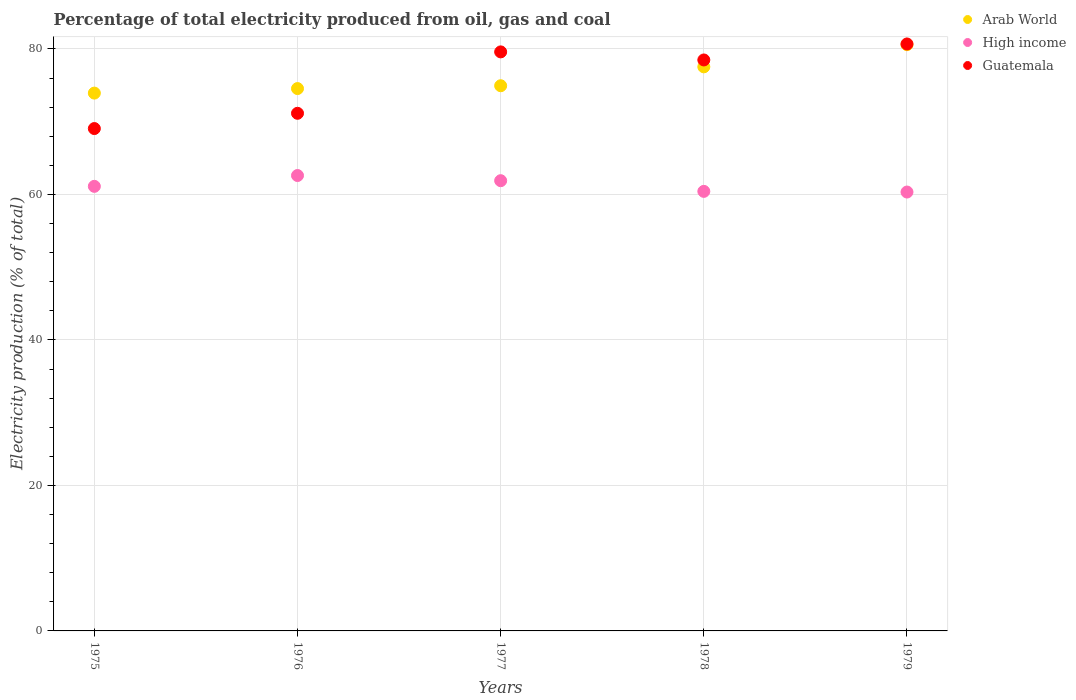Is the number of dotlines equal to the number of legend labels?
Give a very brief answer. Yes. What is the electricity production in in Arab World in 1976?
Offer a very short reply. 74.55. Across all years, what is the maximum electricity production in in Guatemala?
Keep it short and to the point. 80.68. Across all years, what is the minimum electricity production in in Guatemala?
Make the answer very short. 69.05. In which year was the electricity production in in Guatemala maximum?
Your answer should be very brief. 1979. In which year was the electricity production in in Arab World minimum?
Offer a very short reply. 1975. What is the total electricity production in in Arab World in the graph?
Your answer should be compact. 381.53. What is the difference between the electricity production in in Guatemala in 1977 and that in 1978?
Make the answer very short. 1.11. What is the difference between the electricity production in in Guatemala in 1979 and the electricity production in in Arab World in 1977?
Your answer should be compact. 5.74. What is the average electricity production in in Guatemala per year?
Provide a short and direct response. 75.79. In the year 1978, what is the difference between the electricity production in in Arab World and electricity production in in Guatemala?
Your response must be concise. -0.95. In how many years, is the electricity production in in High income greater than 76 %?
Provide a succinct answer. 0. What is the ratio of the electricity production in in High income in 1976 to that in 1978?
Provide a succinct answer. 1.04. Is the electricity production in in High income in 1975 less than that in 1979?
Ensure brevity in your answer.  No. What is the difference between the highest and the second highest electricity production in in Guatemala?
Keep it short and to the point. 1.09. What is the difference between the highest and the lowest electricity production in in Arab World?
Your answer should be compact. 6.66. In how many years, is the electricity production in in High income greater than the average electricity production in in High income taken over all years?
Give a very brief answer. 2. Is it the case that in every year, the sum of the electricity production in in Guatemala and electricity production in in Arab World  is greater than the electricity production in in High income?
Provide a short and direct response. Yes. Is the electricity production in in High income strictly greater than the electricity production in in Guatemala over the years?
Offer a very short reply. No. Is the electricity production in in Guatemala strictly less than the electricity production in in Arab World over the years?
Offer a very short reply. No. How many years are there in the graph?
Your answer should be compact. 5. What is the difference between two consecutive major ticks on the Y-axis?
Your response must be concise. 20. Are the values on the major ticks of Y-axis written in scientific E-notation?
Keep it short and to the point. No. Does the graph contain grids?
Keep it short and to the point. Yes. How many legend labels are there?
Ensure brevity in your answer.  3. What is the title of the graph?
Offer a very short reply. Percentage of total electricity produced from oil, gas and coal. Does "Europe(all income levels)" appear as one of the legend labels in the graph?
Provide a succinct answer. No. What is the label or title of the Y-axis?
Provide a short and direct response. Electricity production (% of total). What is the Electricity production (% of total) of Arab World in 1975?
Make the answer very short. 73.92. What is the Electricity production (% of total) in High income in 1975?
Offer a terse response. 61.11. What is the Electricity production (% of total) in Guatemala in 1975?
Provide a short and direct response. 69.05. What is the Electricity production (% of total) in Arab World in 1976?
Your answer should be compact. 74.55. What is the Electricity production (% of total) in High income in 1976?
Give a very brief answer. 62.6. What is the Electricity production (% of total) in Guatemala in 1976?
Give a very brief answer. 71.15. What is the Electricity production (% of total) in Arab World in 1977?
Give a very brief answer. 74.94. What is the Electricity production (% of total) in High income in 1977?
Your answer should be very brief. 61.89. What is the Electricity production (% of total) of Guatemala in 1977?
Give a very brief answer. 79.59. What is the Electricity production (% of total) of Arab World in 1978?
Provide a succinct answer. 77.53. What is the Electricity production (% of total) of High income in 1978?
Your answer should be compact. 60.42. What is the Electricity production (% of total) of Guatemala in 1978?
Offer a very short reply. 78.48. What is the Electricity production (% of total) of Arab World in 1979?
Offer a very short reply. 80.58. What is the Electricity production (% of total) of High income in 1979?
Provide a short and direct response. 60.33. What is the Electricity production (% of total) in Guatemala in 1979?
Your answer should be very brief. 80.68. Across all years, what is the maximum Electricity production (% of total) of Arab World?
Ensure brevity in your answer.  80.58. Across all years, what is the maximum Electricity production (% of total) in High income?
Your answer should be very brief. 62.6. Across all years, what is the maximum Electricity production (% of total) of Guatemala?
Make the answer very short. 80.68. Across all years, what is the minimum Electricity production (% of total) of Arab World?
Offer a very short reply. 73.92. Across all years, what is the minimum Electricity production (% of total) in High income?
Provide a succinct answer. 60.33. Across all years, what is the minimum Electricity production (% of total) of Guatemala?
Provide a short and direct response. 69.05. What is the total Electricity production (% of total) of Arab World in the graph?
Your answer should be compact. 381.53. What is the total Electricity production (% of total) in High income in the graph?
Provide a short and direct response. 306.34. What is the total Electricity production (% of total) of Guatemala in the graph?
Your answer should be very brief. 378.95. What is the difference between the Electricity production (% of total) in Arab World in 1975 and that in 1976?
Offer a terse response. -0.62. What is the difference between the Electricity production (% of total) of High income in 1975 and that in 1976?
Provide a succinct answer. -1.49. What is the difference between the Electricity production (% of total) in Guatemala in 1975 and that in 1976?
Keep it short and to the point. -2.1. What is the difference between the Electricity production (% of total) of Arab World in 1975 and that in 1977?
Offer a very short reply. -1.01. What is the difference between the Electricity production (% of total) of High income in 1975 and that in 1977?
Give a very brief answer. -0.78. What is the difference between the Electricity production (% of total) of Guatemala in 1975 and that in 1977?
Make the answer very short. -10.54. What is the difference between the Electricity production (% of total) in Arab World in 1975 and that in 1978?
Keep it short and to the point. -3.61. What is the difference between the Electricity production (% of total) of High income in 1975 and that in 1978?
Offer a terse response. 0.69. What is the difference between the Electricity production (% of total) in Guatemala in 1975 and that in 1978?
Your response must be concise. -9.43. What is the difference between the Electricity production (% of total) in Arab World in 1975 and that in 1979?
Provide a short and direct response. -6.66. What is the difference between the Electricity production (% of total) of High income in 1975 and that in 1979?
Your answer should be very brief. 0.78. What is the difference between the Electricity production (% of total) in Guatemala in 1975 and that in 1979?
Offer a terse response. -11.63. What is the difference between the Electricity production (% of total) of Arab World in 1976 and that in 1977?
Ensure brevity in your answer.  -0.39. What is the difference between the Electricity production (% of total) in High income in 1976 and that in 1977?
Your answer should be very brief. 0.71. What is the difference between the Electricity production (% of total) of Guatemala in 1976 and that in 1977?
Keep it short and to the point. -8.44. What is the difference between the Electricity production (% of total) of Arab World in 1976 and that in 1978?
Your answer should be very brief. -2.99. What is the difference between the Electricity production (% of total) of High income in 1976 and that in 1978?
Offer a terse response. 2.18. What is the difference between the Electricity production (% of total) in Guatemala in 1976 and that in 1978?
Make the answer very short. -7.33. What is the difference between the Electricity production (% of total) in Arab World in 1976 and that in 1979?
Provide a short and direct response. -6.03. What is the difference between the Electricity production (% of total) in High income in 1976 and that in 1979?
Your response must be concise. 2.27. What is the difference between the Electricity production (% of total) in Guatemala in 1976 and that in 1979?
Provide a succinct answer. -9.53. What is the difference between the Electricity production (% of total) in Arab World in 1977 and that in 1978?
Provide a succinct answer. -2.6. What is the difference between the Electricity production (% of total) in High income in 1977 and that in 1978?
Give a very brief answer. 1.47. What is the difference between the Electricity production (% of total) in Guatemala in 1977 and that in 1978?
Offer a terse response. 1.11. What is the difference between the Electricity production (% of total) of Arab World in 1977 and that in 1979?
Your answer should be compact. -5.64. What is the difference between the Electricity production (% of total) of High income in 1977 and that in 1979?
Keep it short and to the point. 1.56. What is the difference between the Electricity production (% of total) in Guatemala in 1977 and that in 1979?
Provide a short and direct response. -1.09. What is the difference between the Electricity production (% of total) in Arab World in 1978 and that in 1979?
Your answer should be very brief. -3.05. What is the difference between the Electricity production (% of total) of High income in 1978 and that in 1979?
Offer a terse response. 0.09. What is the difference between the Electricity production (% of total) in Guatemala in 1978 and that in 1979?
Ensure brevity in your answer.  -2.2. What is the difference between the Electricity production (% of total) of Arab World in 1975 and the Electricity production (% of total) of High income in 1976?
Make the answer very short. 11.33. What is the difference between the Electricity production (% of total) in Arab World in 1975 and the Electricity production (% of total) in Guatemala in 1976?
Your response must be concise. 2.78. What is the difference between the Electricity production (% of total) in High income in 1975 and the Electricity production (% of total) in Guatemala in 1976?
Keep it short and to the point. -10.04. What is the difference between the Electricity production (% of total) of Arab World in 1975 and the Electricity production (% of total) of High income in 1977?
Make the answer very short. 12.04. What is the difference between the Electricity production (% of total) of Arab World in 1975 and the Electricity production (% of total) of Guatemala in 1977?
Provide a short and direct response. -5.67. What is the difference between the Electricity production (% of total) of High income in 1975 and the Electricity production (% of total) of Guatemala in 1977?
Provide a short and direct response. -18.48. What is the difference between the Electricity production (% of total) in Arab World in 1975 and the Electricity production (% of total) in High income in 1978?
Ensure brevity in your answer.  13.51. What is the difference between the Electricity production (% of total) of Arab World in 1975 and the Electricity production (% of total) of Guatemala in 1978?
Provide a short and direct response. -4.56. What is the difference between the Electricity production (% of total) in High income in 1975 and the Electricity production (% of total) in Guatemala in 1978?
Give a very brief answer. -17.37. What is the difference between the Electricity production (% of total) of Arab World in 1975 and the Electricity production (% of total) of High income in 1979?
Offer a terse response. 13.6. What is the difference between the Electricity production (% of total) in Arab World in 1975 and the Electricity production (% of total) in Guatemala in 1979?
Provide a succinct answer. -6.75. What is the difference between the Electricity production (% of total) in High income in 1975 and the Electricity production (% of total) in Guatemala in 1979?
Give a very brief answer. -19.57. What is the difference between the Electricity production (% of total) in Arab World in 1976 and the Electricity production (% of total) in High income in 1977?
Your answer should be very brief. 12.66. What is the difference between the Electricity production (% of total) of Arab World in 1976 and the Electricity production (% of total) of Guatemala in 1977?
Your answer should be very brief. -5.04. What is the difference between the Electricity production (% of total) of High income in 1976 and the Electricity production (% of total) of Guatemala in 1977?
Provide a short and direct response. -16.99. What is the difference between the Electricity production (% of total) in Arab World in 1976 and the Electricity production (% of total) in High income in 1978?
Provide a short and direct response. 14.13. What is the difference between the Electricity production (% of total) in Arab World in 1976 and the Electricity production (% of total) in Guatemala in 1978?
Keep it short and to the point. -3.93. What is the difference between the Electricity production (% of total) in High income in 1976 and the Electricity production (% of total) in Guatemala in 1978?
Give a very brief answer. -15.88. What is the difference between the Electricity production (% of total) in Arab World in 1976 and the Electricity production (% of total) in High income in 1979?
Keep it short and to the point. 14.22. What is the difference between the Electricity production (% of total) of Arab World in 1976 and the Electricity production (% of total) of Guatemala in 1979?
Give a very brief answer. -6.13. What is the difference between the Electricity production (% of total) in High income in 1976 and the Electricity production (% of total) in Guatemala in 1979?
Give a very brief answer. -18.08. What is the difference between the Electricity production (% of total) of Arab World in 1977 and the Electricity production (% of total) of High income in 1978?
Ensure brevity in your answer.  14.52. What is the difference between the Electricity production (% of total) in Arab World in 1977 and the Electricity production (% of total) in Guatemala in 1978?
Ensure brevity in your answer.  -3.54. What is the difference between the Electricity production (% of total) in High income in 1977 and the Electricity production (% of total) in Guatemala in 1978?
Your answer should be very brief. -16.6. What is the difference between the Electricity production (% of total) of Arab World in 1977 and the Electricity production (% of total) of High income in 1979?
Your answer should be compact. 14.61. What is the difference between the Electricity production (% of total) in Arab World in 1977 and the Electricity production (% of total) in Guatemala in 1979?
Your answer should be compact. -5.74. What is the difference between the Electricity production (% of total) of High income in 1977 and the Electricity production (% of total) of Guatemala in 1979?
Offer a terse response. -18.79. What is the difference between the Electricity production (% of total) of Arab World in 1978 and the Electricity production (% of total) of High income in 1979?
Provide a succinct answer. 17.21. What is the difference between the Electricity production (% of total) of Arab World in 1978 and the Electricity production (% of total) of Guatemala in 1979?
Offer a very short reply. -3.14. What is the difference between the Electricity production (% of total) in High income in 1978 and the Electricity production (% of total) in Guatemala in 1979?
Provide a succinct answer. -20.26. What is the average Electricity production (% of total) of Arab World per year?
Provide a succinct answer. 76.31. What is the average Electricity production (% of total) in High income per year?
Your answer should be very brief. 61.27. What is the average Electricity production (% of total) of Guatemala per year?
Ensure brevity in your answer.  75.79. In the year 1975, what is the difference between the Electricity production (% of total) of Arab World and Electricity production (% of total) of High income?
Make the answer very short. 12.82. In the year 1975, what is the difference between the Electricity production (% of total) in Arab World and Electricity production (% of total) in Guatemala?
Provide a short and direct response. 4.87. In the year 1975, what is the difference between the Electricity production (% of total) of High income and Electricity production (% of total) of Guatemala?
Make the answer very short. -7.94. In the year 1976, what is the difference between the Electricity production (% of total) of Arab World and Electricity production (% of total) of High income?
Offer a terse response. 11.95. In the year 1976, what is the difference between the Electricity production (% of total) in Arab World and Electricity production (% of total) in Guatemala?
Keep it short and to the point. 3.4. In the year 1976, what is the difference between the Electricity production (% of total) of High income and Electricity production (% of total) of Guatemala?
Keep it short and to the point. -8.55. In the year 1977, what is the difference between the Electricity production (% of total) in Arab World and Electricity production (% of total) in High income?
Make the answer very short. 13.05. In the year 1977, what is the difference between the Electricity production (% of total) of Arab World and Electricity production (% of total) of Guatemala?
Offer a terse response. -4.65. In the year 1977, what is the difference between the Electricity production (% of total) of High income and Electricity production (% of total) of Guatemala?
Keep it short and to the point. -17.7. In the year 1978, what is the difference between the Electricity production (% of total) of Arab World and Electricity production (% of total) of High income?
Make the answer very short. 17.12. In the year 1978, what is the difference between the Electricity production (% of total) of Arab World and Electricity production (% of total) of Guatemala?
Keep it short and to the point. -0.95. In the year 1978, what is the difference between the Electricity production (% of total) of High income and Electricity production (% of total) of Guatemala?
Offer a very short reply. -18.06. In the year 1979, what is the difference between the Electricity production (% of total) of Arab World and Electricity production (% of total) of High income?
Offer a very short reply. 20.25. In the year 1979, what is the difference between the Electricity production (% of total) of Arab World and Electricity production (% of total) of Guatemala?
Your answer should be very brief. -0.1. In the year 1979, what is the difference between the Electricity production (% of total) in High income and Electricity production (% of total) in Guatemala?
Your answer should be compact. -20.35. What is the ratio of the Electricity production (% of total) of High income in 1975 to that in 1976?
Offer a very short reply. 0.98. What is the ratio of the Electricity production (% of total) of Guatemala in 1975 to that in 1976?
Your answer should be compact. 0.97. What is the ratio of the Electricity production (% of total) of Arab World in 1975 to that in 1977?
Ensure brevity in your answer.  0.99. What is the ratio of the Electricity production (% of total) in High income in 1975 to that in 1977?
Provide a short and direct response. 0.99. What is the ratio of the Electricity production (% of total) in Guatemala in 1975 to that in 1977?
Your response must be concise. 0.87. What is the ratio of the Electricity production (% of total) in Arab World in 1975 to that in 1978?
Your answer should be very brief. 0.95. What is the ratio of the Electricity production (% of total) in High income in 1975 to that in 1978?
Ensure brevity in your answer.  1.01. What is the ratio of the Electricity production (% of total) of Guatemala in 1975 to that in 1978?
Provide a succinct answer. 0.88. What is the ratio of the Electricity production (% of total) in Arab World in 1975 to that in 1979?
Offer a very short reply. 0.92. What is the ratio of the Electricity production (% of total) in High income in 1975 to that in 1979?
Offer a terse response. 1.01. What is the ratio of the Electricity production (% of total) in Guatemala in 1975 to that in 1979?
Offer a terse response. 0.86. What is the ratio of the Electricity production (% of total) of High income in 1976 to that in 1977?
Make the answer very short. 1.01. What is the ratio of the Electricity production (% of total) in Guatemala in 1976 to that in 1977?
Keep it short and to the point. 0.89. What is the ratio of the Electricity production (% of total) in Arab World in 1976 to that in 1978?
Your response must be concise. 0.96. What is the ratio of the Electricity production (% of total) in High income in 1976 to that in 1978?
Ensure brevity in your answer.  1.04. What is the ratio of the Electricity production (% of total) of Guatemala in 1976 to that in 1978?
Make the answer very short. 0.91. What is the ratio of the Electricity production (% of total) of Arab World in 1976 to that in 1979?
Make the answer very short. 0.93. What is the ratio of the Electricity production (% of total) in High income in 1976 to that in 1979?
Keep it short and to the point. 1.04. What is the ratio of the Electricity production (% of total) in Guatemala in 1976 to that in 1979?
Your answer should be very brief. 0.88. What is the ratio of the Electricity production (% of total) in Arab World in 1977 to that in 1978?
Your response must be concise. 0.97. What is the ratio of the Electricity production (% of total) in High income in 1977 to that in 1978?
Offer a very short reply. 1.02. What is the ratio of the Electricity production (% of total) in Guatemala in 1977 to that in 1978?
Give a very brief answer. 1.01. What is the ratio of the Electricity production (% of total) of Arab World in 1977 to that in 1979?
Provide a short and direct response. 0.93. What is the ratio of the Electricity production (% of total) in High income in 1977 to that in 1979?
Make the answer very short. 1.03. What is the ratio of the Electricity production (% of total) in Guatemala in 1977 to that in 1979?
Offer a very short reply. 0.99. What is the ratio of the Electricity production (% of total) of Arab World in 1978 to that in 1979?
Your answer should be compact. 0.96. What is the ratio of the Electricity production (% of total) of High income in 1978 to that in 1979?
Your response must be concise. 1. What is the ratio of the Electricity production (% of total) in Guatemala in 1978 to that in 1979?
Ensure brevity in your answer.  0.97. What is the difference between the highest and the second highest Electricity production (% of total) in Arab World?
Ensure brevity in your answer.  3.05. What is the difference between the highest and the second highest Electricity production (% of total) of High income?
Your response must be concise. 0.71. What is the difference between the highest and the second highest Electricity production (% of total) in Guatemala?
Your answer should be very brief. 1.09. What is the difference between the highest and the lowest Electricity production (% of total) in Arab World?
Give a very brief answer. 6.66. What is the difference between the highest and the lowest Electricity production (% of total) of High income?
Provide a short and direct response. 2.27. What is the difference between the highest and the lowest Electricity production (% of total) in Guatemala?
Your answer should be very brief. 11.63. 